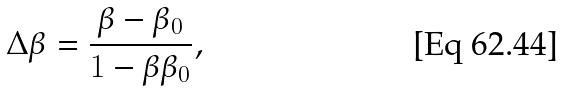<formula> <loc_0><loc_0><loc_500><loc_500>\Delta \beta = \frac { \beta - \beta _ { 0 } } { 1 - \beta \beta _ { 0 } } ,</formula> 